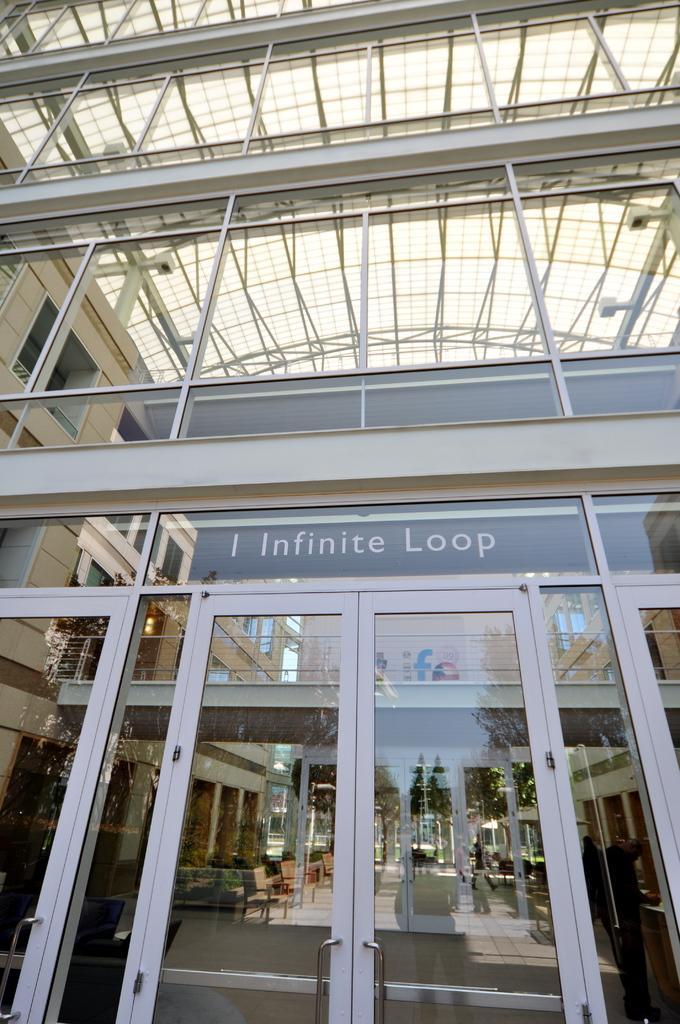Could you give a brief overview of what you see in this image? In this picture we can see the building. At the bottom we can see the doors. Through we can see the table and chairs. In the reflection we can see sky, flags and the person. 